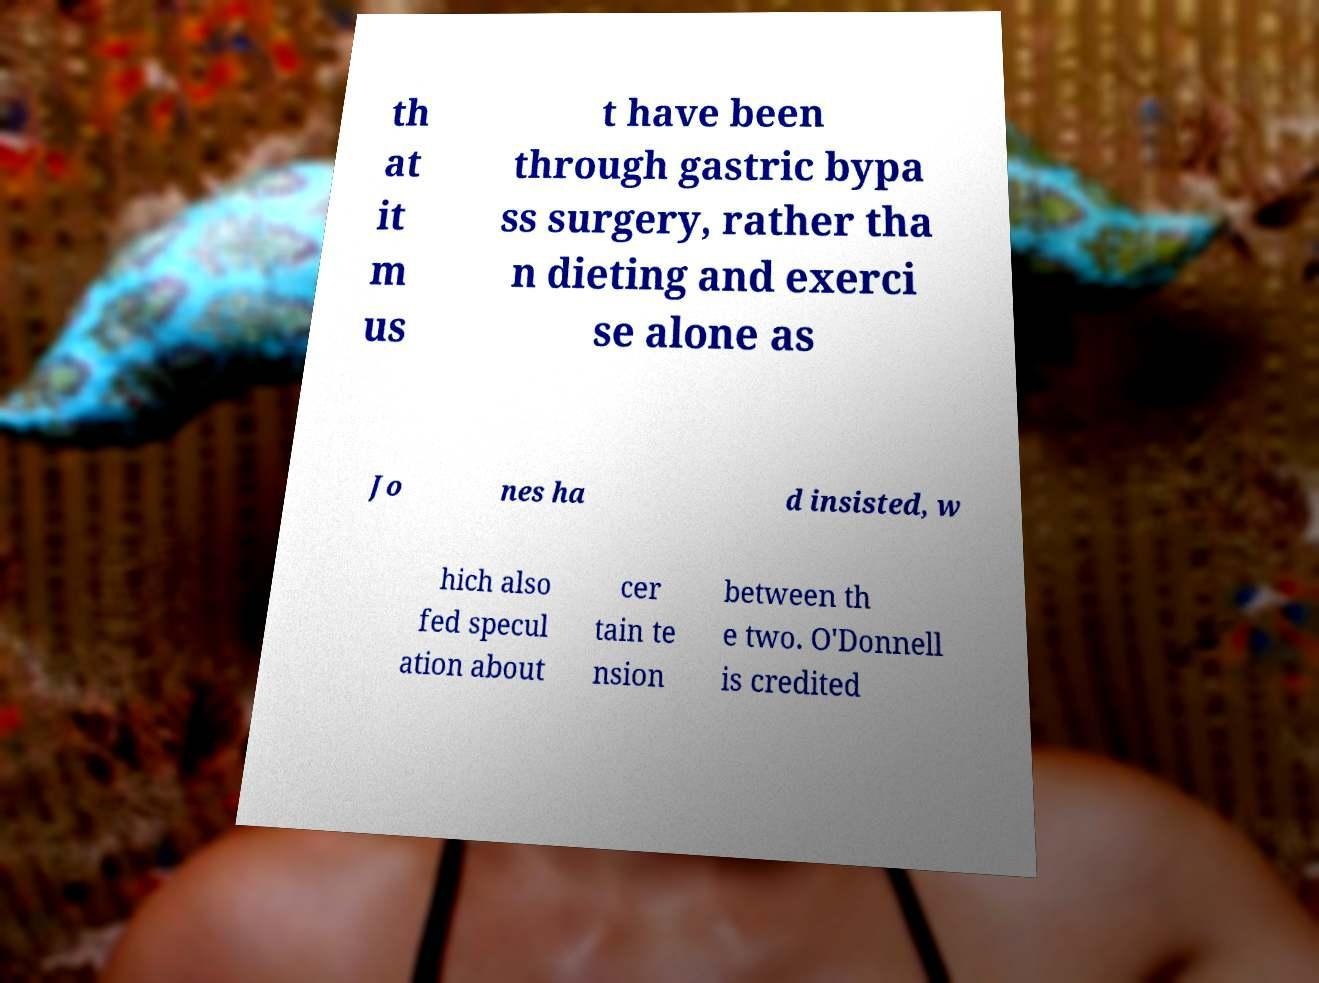Can you accurately transcribe the text from the provided image for me? th at it m us t have been through gastric bypa ss surgery, rather tha n dieting and exerci se alone as Jo nes ha d insisted, w hich also fed specul ation about cer tain te nsion between th e two. O'Donnell is credited 